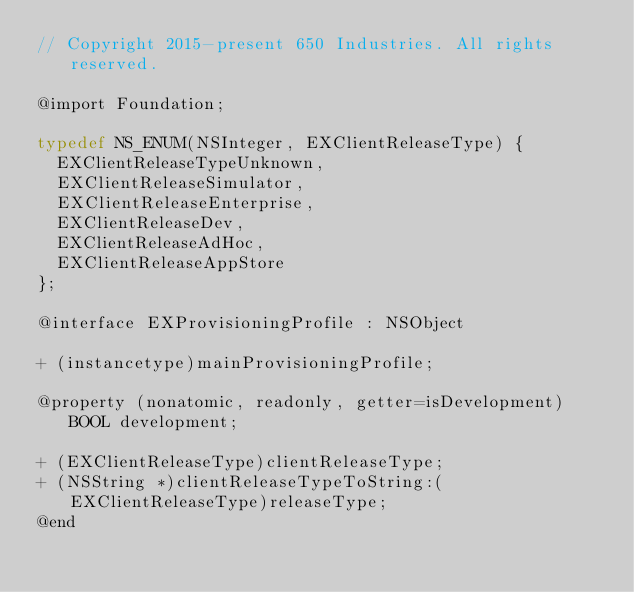Convert code to text. <code><loc_0><loc_0><loc_500><loc_500><_C_>// Copyright 2015-present 650 Industries. All rights reserved.

@import Foundation;

typedef NS_ENUM(NSInteger, EXClientReleaseType) {
  EXClientReleaseTypeUnknown,
  EXClientReleaseSimulator,
  EXClientReleaseEnterprise,
  EXClientReleaseDev,
  EXClientReleaseAdHoc,
  EXClientReleaseAppStore
};

@interface EXProvisioningProfile : NSObject

+ (instancetype)mainProvisioningProfile;

@property (nonatomic, readonly, getter=isDevelopment) BOOL development;

+ (EXClientReleaseType)clientReleaseType;
+ (NSString *)clientReleaseTypeToString:(EXClientReleaseType)releaseType;
@end
</code> 